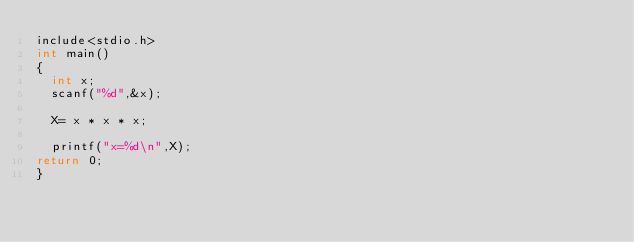<code> <loc_0><loc_0><loc_500><loc_500><_C_>include<stdio.h>
int main()
{
	int x;
	scanf("%d",&x);

	X= x * x * x;

	printf("x=%d\n",X);
return 0;
}</code> 